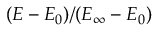Convert formula to latex. <formula><loc_0><loc_0><loc_500><loc_500>( E - E _ { 0 } ) / ( E _ { \infty } - E _ { 0 } )</formula> 